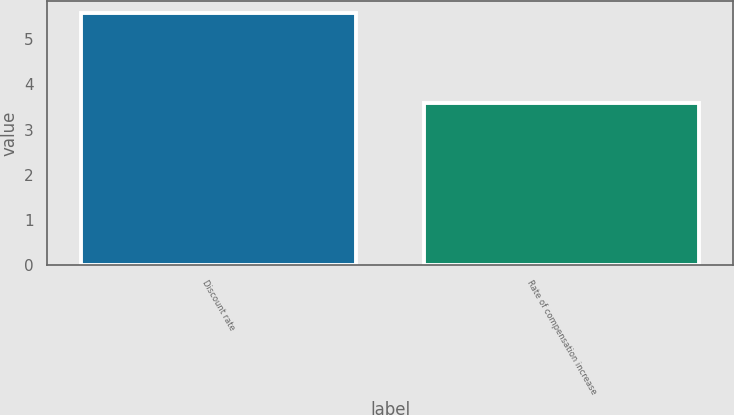Convert chart. <chart><loc_0><loc_0><loc_500><loc_500><bar_chart><fcel>Discount rate<fcel>Rate of compensation increase<nl><fcel>5.57<fcel>3.59<nl></chart> 